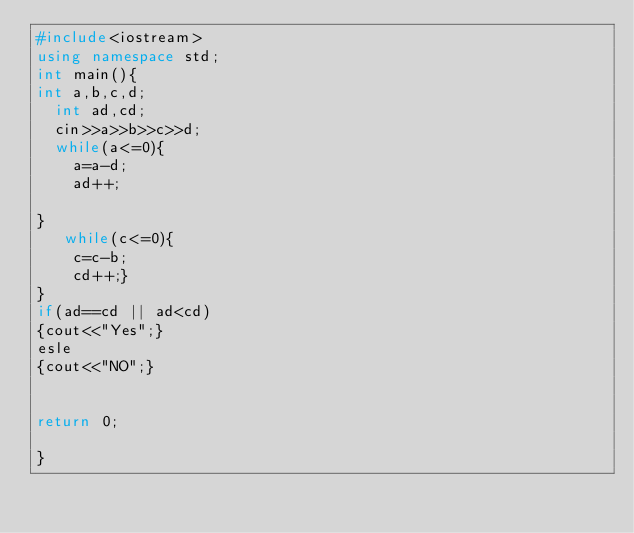<code> <loc_0><loc_0><loc_500><loc_500><_C++_>#include<iostream>
using namespace std;
int main(){
int a,b,c,d;
  int ad,cd;
  cin>>a>>b>>c>>d;
  while(a<=0){
    a=a-d;
    ad++;
   
}
   while(c<=0){
    c=c-b;
    cd++;}
}
if(ad==cd || ad<cd)
{cout<<"Yes";}
esle
{cout<<"NO";}
  
  
return 0;
 
}</code> 